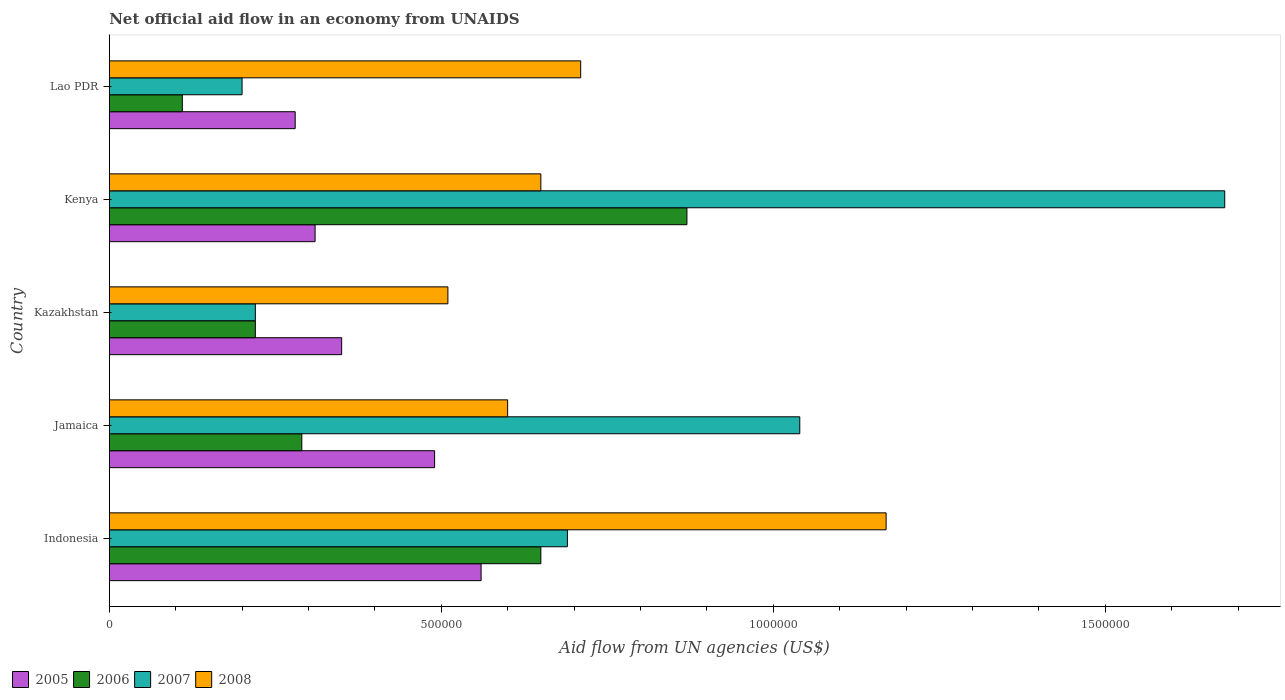How many groups of bars are there?
Keep it short and to the point. 5. How many bars are there on the 3rd tick from the top?
Make the answer very short. 4. What is the label of the 4th group of bars from the top?
Offer a terse response. Jamaica. In how many cases, is the number of bars for a given country not equal to the number of legend labels?
Your answer should be compact. 0. What is the net official aid flow in 2006 in Jamaica?
Give a very brief answer. 2.90e+05. Across all countries, what is the maximum net official aid flow in 2006?
Offer a terse response. 8.70e+05. In which country was the net official aid flow in 2005 minimum?
Provide a short and direct response. Lao PDR. What is the total net official aid flow in 2007 in the graph?
Keep it short and to the point. 3.83e+06. What is the difference between the net official aid flow in 2008 in Indonesia and that in Kenya?
Offer a terse response. 5.20e+05. What is the difference between the net official aid flow in 2005 in Kazakhstan and the net official aid flow in 2007 in Jamaica?
Keep it short and to the point. -6.90e+05. What is the average net official aid flow in 2006 per country?
Provide a short and direct response. 4.28e+05. What is the difference between the net official aid flow in 2008 and net official aid flow in 2006 in Indonesia?
Your answer should be very brief. 5.20e+05. Is the difference between the net official aid flow in 2008 in Kazakhstan and Kenya greater than the difference between the net official aid flow in 2006 in Kazakhstan and Kenya?
Make the answer very short. Yes. What is the difference between the highest and the second highest net official aid flow in 2007?
Offer a terse response. 6.40e+05. What is the difference between the highest and the lowest net official aid flow in 2006?
Provide a succinct answer. 7.60e+05. Is the sum of the net official aid flow in 2006 in Indonesia and Jamaica greater than the maximum net official aid flow in 2005 across all countries?
Provide a succinct answer. Yes. Is it the case that in every country, the sum of the net official aid flow in 2007 and net official aid flow in 2005 is greater than the sum of net official aid flow in 2006 and net official aid flow in 2008?
Ensure brevity in your answer.  No. What does the 2nd bar from the top in Kenya represents?
Provide a short and direct response. 2007. Is it the case that in every country, the sum of the net official aid flow in 2006 and net official aid flow in 2007 is greater than the net official aid flow in 2005?
Offer a very short reply. Yes. How many bars are there?
Offer a very short reply. 20. How many countries are there in the graph?
Provide a short and direct response. 5. What is the difference between two consecutive major ticks on the X-axis?
Offer a very short reply. 5.00e+05. Are the values on the major ticks of X-axis written in scientific E-notation?
Your response must be concise. No. Does the graph contain any zero values?
Give a very brief answer. No. Where does the legend appear in the graph?
Your answer should be compact. Bottom left. How many legend labels are there?
Provide a succinct answer. 4. How are the legend labels stacked?
Your answer should be very brief. Horizontal. What is the title of the graph?
Your response must be concise. Net official aid flow in an economy from UNAIDS. What is the label or title of the X-axis?
Your answer should be compact. Aid flow from UN agencies (US$). What is the label or title of the Y-axis?
Provide a succinct answer. Country. What is the Aid flow from UN agencies (US$) of 2005 in Indonesia?
Give a very brief answer. 5.60e+05. What is the Aid flow from UN agencies (US$) in 2006 in Indonesia?
Offer a very short reply. 6.50e+05. What is the Aid flow from UN agencies (US$) in 2007 in Indonesia?
Offer a very short reply. 6.90e+05. What is the Aid flow from UN agencies (US$) of 2008 in Indonesia?
Offer a terse response. 1.17e+06. What is the Aid flow from UN agencies (US$) in 2005 in Jamaica?
Give a very brief answer. 4.90e+05. What is the Aid flow from UN agencies (US$) in 2007 in Jamaica?
Your response must be concise. 1.04e+06. What is the Aid flow from UN agencies (US$) in 2008 in Jamaica?
Offer a very short reply. 6.00e+05. What is the Aid flow from UN agencies (US$) of 2006 in Kazakhstan?
Offer a terse response. 2.20e+05. What is the Aid flow from UN agencies (US$) in 2007 in Kazakhstan?
Your answer should be compact. 2.20e+05. What is the Aid flow from UN agencies (US$) of 2008 in Kazakhstan?
Your answer should be very brief. 5.10e+05. What is the Aid flow from UN agencies (US$) in 2006 in Kenya?
Provide a succinct answer. 8.70e+05. What is the Aid flow from UN agencies (US$) of 2007 in Kenya?
Provide a succinct answer. 1.68e+06. What is the Aid flow from UN agencies (US$) of 2008 in Kenya?
Your answer should be very brief. 6.50e+05. What is the Aid flow from UN agencies (US$) in 2005 in Lao PDR?
Your response must be concise. 2.80e+05. What is the Aid flow from UN agencies (US$) of 2006 in Lao PDR?
Give a very brief answer. 1.10e+05. What is the Aid flow from UN agencies (US$) in 2007 in Lao PDR?
Your answer should be compact. 2.00e+05. What is the Aid flow from UN agencies (US$) of 2008 in Lao PDR?
Ensure brevity in your answer.  7.10e+05. Across all countries, what is the maximum Aid flow from UN agencies (US$) in 2005?
Provide a short and direct response. 5.60e+05. Across all countries, what is the maximum Aid flow from UN agencies (US$) in 2006?
Provide a succinct answer. 8.70e+05. Across all countries, what is the maximum Aid flow from UN agencies (US$) of 2007?
Offer a terse response. 1.68e+06. Across all countries, what is the maximum Aid flow from UN agencies (US$) of 2008?
Provide a short and direct response. 1.17e+06. Across all countries, what is the minimum Aid flow from UN agencies (US$) in 2005?
Provide a short and direct response. 2.80e+05. Across all countries, what is the minimum Aid flow from UN agencies (US$) in 2006?
Ensure brevity in your answer.  1.10e+05. Across all countries, what is the minimum Aid flow from UN agencies (US$) of 2008?
Offer a very short reply. 5.10e+05. What is the total Aid flow from UN agencies (US$) of 2005 in the graph?
Your response must be concise. 1.99e+06. What is the total Aid flow from UN agencies (US$) in 2006 in the graph?
Offer a very short reply. 2.14e+06. What is the total Aid flow from UN agencies (US$) in 2007 in the graph?
Your answer should be compact. 3.83e+06. What is the total Aid flow from UN agencies (US$) of 2008 in the graph?
Your answer should be very brief. 3.64e+06. What is the difference between the Aid flow from UN agencies (US$) of 2005 in Indonesia and that in Jamaica?
Your response must be concise. 7.00e+04. What is the difference between the Aid flow from UN agencies (US$) in 2006 in Indonesia and that in Jamaica?
Ensure brevity in your answer.  3.60e+05. What is the difference between the Aid flow from UN agencies (US$) in 2007 in Indonesia and that in Jamaica?
Offer a terse response. -3.50e+05. What is the difference between the Aid flow from UN agencies (US$) in 2008 in Indonesia and that in Jamaica?
Make the answer very short. 5.70e+05. What is the difference between the Aid flow from UN agencies (US$) of 2007 in Indonesia and that in Kazakhstan?
Your answer should be compact. 4.70e+05. What is the difference between the Aid flow from UN agencies (US$) in 2008 in Indonesia and that in Kazakhstan?
Your response must be concise. 6.60e+05. What is the difference between the Aid flow from UN agencies (US$) in 2005 in Indonesia and that in Kenya?
Provide a succinct answer. 2.50e+05. What is the difference between the Aid flow from UN agencies (US$) of 2006 in Indonesia and that in Kenya?
Offer a terse response. -2.20e+05. What is the difference between the Aid flow from UN agencies (US$) in 2007 in Indonesia and that in Kenya?
Your answer should be compact. -9.90e+05. What is the difference between the Aid flow from UN agencies (US$) in 2008 in Indonesia and that in Kenya?
Provide a succinct answer. 5.20e+05. What is the difference between the Aid flow from UN agencies (US$) in 2006 in Indonesia and that in Lao PDR?
Offer a very short reply. 5.40e+05. What is the difference between the Aid flow from UN agencies (US$) of 2006 in Jamaica and that in Kazakhstan?
Keep it short and to the point. 7.00e+04. What is the difference between the Aid flow from UN agencies (US$) in 2007 in Jamaica and that in Kazakhstan?
Give a very brief answer. 8.20e+05. What is the difference between the Aid flow from UN agencies (US$) of 2008 in Jamaica and that in Kazakhstan?
Your answer should be very brief. 9.00e+04. What is the difference between the Aid flow from UN agencies (US$) in 2006 in Jamaica and that in Kenya?
Ensure brevity in your answer.  -5.80e+05. What is the difference between the Aid flow from UN agencies (US$) in 2007 in Jamaica and that in Kenya?
Your answer should be very brief. -6.40e+05. What is the difference between the Aid flow from UN agencies (US$) in 2005 in Jamaica and that in Lao PDR?
Your response must be concise. 2.10e+05. What is the difference between the Aid flow from UN agencies (US$) in 2006 in Jamaica and that in Lao PDR?
Offer a terse response. 1.80e+05. What is the difference between the Aid flow from UN agencies (US$) of 2007 in Jamaica and that in Lao PDR?
Your answer should be compact. 8.40e+05. What is the difference between the Aid flow from UN agencies (US$) of 2008 in Jamaica and that in Lao PDR?
Your answer should be compact. -1.10e+05. What is the difference between the Aid flow from UN agencies (US$) in 2006 in Kazakhstan and that in Kenya?
Make the answer very short. -6.50e+05. What is the difference between the Aid flow from UN agencies (US$) of 2007 in Kazakhstan and that in Kenya?
Give a very brief answer. -1.46e+06. What is the difference between the Aid flow from UN agencies (US$) of 2006 in Kazakhstan and that in Lao PDR?
Your answer should be compact. 1.10e+05. What is the difference between the Aid flow from UN agencies (US$) in 2005 in Kenya and that in Lao PDR?
Ensure brevity in your answer.  3.00e+04. What is the difference between the Aid flow from UN agencies (US$) in 2006 in Kenya and that in Lao PDR?
Give a very brief answer. 7.60e+05. What is the difference between the Aid flow from UN agencies (US$) in 2007 in Kenya and that in Lao PDR?
Make the answer very short. 1.48e+06. What is the difference between the Aid flow from UN agencies (US$) of 2008 in Kenya and that in Lao PDR?
Provide a succinct answer. -6.00e+04. What is the difference between the Aid flow from UN agencies (US$) in 2005 in Indonesia and the Aid flow from UN agencies (US$) in 2007 in Jamaica?
Your response must be concise. -4.80e+05. What is the difference between the Aid flow from UN agencies (US$) of 2005 in Indonesia and the Aid flow from UN agencies (US$) of 2008 in Jamaica?
Your answer should be very brief. -4.00e+04. What is the difference between the Aid flow from UN agencies (US$) in 2006 in Indonesia and the Aid flow from UN agencies (US$) in 2007 in Jamaica?
Your answer should be very brief. -3.90e+05. What is the difference between the Aid flow from UN agencies (US$) in 2006 in Indonesia and the Aid flow from UN agencies (US$) in 2008 in Jamaica?
Ensure brevity in your answer.  5.00e+04. What is the difference between the Aid flow from UN agencies (US$) of 2005 in Indonesia and the Aid flow from UN agencies (US$) of 2006 in Kazakhstan?
Your response must be concise. 3.40e+05. What is the difference between the Aid flow from UN agencies (US$) of 2005 in Indonesia and the Aid flow from UN agencies (US$) of 2007 in Kazakhstan?
Your response must be concise. 3.40e+05. What is the difference between the Aid flow from UN agencies (US$) of 2006 in Indonesia and the Aid flow from UN agencies (US$) of 2007 in Kazakhstan?
Your answer should be compact. 4.30e+05. What is the difference between the Aid flow from UN agencies (US$) in 2007 in Indonesia and the Aid flow from UN agencies (US$) in 2008 in Kazakhstan?
Offer a terse response. 1.80e+05. What is the difference between the Aid flow from UN agencies (US$) of 2005 in Indonesia and the Aid flow from UN agencies (US$) of 2006 in Kenya?
Ensure brevity in your answer.  -3.10e+05. What is the difference between the Aid flow from UN agencies (US$) of 2005 in Indonesia and the Aid flow from UN agencies (US$) of 2007 in Kenya?
Offer a very short reply. -1.12e+06. What is the difference between the Aid flow from UN agencies (US$) of 2006 in Indonesia and the Aid flow from UN agencies (US$) of 2007 in Kenya?
Give a very brief answer. -1.03e+06. What is the difference between the Aid flow from UN agencies (US$) in 2006 in Indonesia and the Aid flow from UN agencies (US$) in 2008 in Kenya?
Provide a short and direct response. 0. What is the difference between the Aid flow from UN agencies (US$) of 2005 in Indonesia and the Aid flow from UN agencies (US$) of 2006 in Lao PDR?
Keep it short and to the point. 4.50e+05. What is the difference between the Aid flow from UN agencies (US$) of 2005 in Indonesia and the Aid flow from UN agencies (US$) of 2007 in Lao PDR?
Ensure brevity in your answer.  3.60e+05. What is the difference between the Aid flow from UN agencies (US$) of 2006 in Indonesia and the Aid flow from UN agencies (US$) of 2007 in Lao PDR?
Provide a succinct answer. 4.50e+05. What is the difference between the Aid flow from UN agencies (US$) of 2006 in Indonesia and the Aid flow from UN agencies (US$) of 2008 in Lao PDR?
Give a very brief answer. -6.00e+04. What is the difference between the Aid flow from UN agencies (US$) of 2005 in Jamaica and the Aid flow from UN agencies (US$) of 2007 in Kazakhstan?
Make the answer very short. 2.70e+05. What is the difference between the Aid flow from UN agencies (US$) in 2006 in Jamaica and the Aid flow from UN agencies (US$) in 2007 in Kazakhstan?
Make the answer very short. 7.00e+04. What is the difference between the Aid flow from UN agencies (US$) in 2006 in Jamaica and the Aid flow from UN agencies (US$) in 2008 in Kazakhstan?
Offer a very short reply. -2.20e+05. What is the difference between the Aid flow from UN agencies (US$) of 2007 in Jamaica and the Aid flow from UN agencies (US$) of 2008 in Kazakhstan?
Give a very brief answer. 5.30e+05. What is the difference between the Aid flow from UN agencies (US$) of 2005 in Jamaica and the Aid flow from UN agencies (US$) of 2006 in Kenya?
Offer a very short reply. -3.80e+05. What is the difference between the Aid flow from UN agencies (US$) of 2005 in Jamaica and the Aid flow from UN agencies (US$) of 2007 in Kenya?
Provide a short and direct response. -1.19e+06. What is the difference between the Aid flow from UN agencies (US$) of 2006 in Jamaica and the Aid flow from UN agencies (US$) of 2007 in Kenya?
Ensure brevity in your answer.  -1.39e+06. What is the difference between the Aid flow from UN agencies (US$) in 2006 in Jamaica and the Aid flow from UN agencies (US$) in 2008 in Kenya?
Provide a succinct answer. -3.60e+05. What is the difference between the Aid flow from UN agencies (US$) of 2005 in Jamaica and the Aid flow from UN agencies (US$) of 2006 in Lao PDR?
Provide a succinct answer. 3.80e+05. What is the difference between the Aid flow from UN agencies (US$) of 2005 in Jamaica and the Aid flow from UN agencies (US$) of 2008 in Lao PDR?
Ensure brevity in your answer.  -2.20e+05. What is the difference between the Aid flow from UN agencies (US$) of 2006 in Jamaica and the Aid flow from UN agencies (US$) of 2007 in Lao PDR?
Your answer should be very brief. 9.00e+04. What is the difference between the Aid flow from UN agencies (US$) of 2006 in Jamaica and the Aid flow from UN agencies (US$) of 2008 in Lao PDR?
Provide a short and direct response. -4.20e+05. What is the difference between the Aid flow from UN agencies (US$) in 2005 in Kazakhstan and the Aid flow from UN agencies (US$) in 2006 in Kenya?
Ensure brevity in your answer.  -5.20e+05. What is the difference between the Aid flow from UN agencies (US$) of 2005 in Kazakhstan and the Aid flow from UN agencies (US$) of 2007 in Kenya?
Offer a terse response. -1.33e+06. What is the difference between the Aid flow from UN agencies (US$) in 2005 in Kazakhstan and the Aid flow from UN agencies (US$) in 2008 in Kenya?
Your answer should be very brief. -3.00e+05. What is the difference between the Aid flow from UN agencies (US$) in 2006 in Kazakhstan and the Aid flow from UN agencies (US$) in 2007 in Kenya?
Keep it short and to the point. -1.46e+06. What is the difference between the Aid flow from UN agencies (US$) in 2006 in Kazakhstan and the Aid flow from UN agencies (US$) in 2008 in Kenya?
Ensure brevity in your answer.  -4.30e+05. What is the difference between the Aid flow from UN agencies (US$) of 2007 in Kazakhstan and the Aid flow from UN agencies (US$) of 2008 in Kenya?
Make the answer very short. -4.30e+05. What is the difference between the Aid flow from UN agencies (US$) of 2005 in Kazakhstan and the Aid flow from UN agencies (US$) of 2006 in Lao PDR?
Offer a terse response. 2.40e+05. What is the difference between the Aid flow from UN agencies (US$) in 2005 in Kazakhstan and the Aid flow from UN agencies (US$) in 2008 in Lao PDR?
Keep it short and to the point. -3.60e+05. What is the difference between the Aid flow from UN agencies (US$) in 2006 in Kazakhstan and the Aid flow from UN agencies (US$) in 2007 in Lao PDR?
Provide a succinct answer. 2.00e+04. What is the difference between the Aid flow from UN agencies (US$) in 2006 in Kazakhstan and the Aid flow from UN agencies (US$) in 2008 in Lao PDR?
Offer a terse response. -4.90e+05. What is the difference between the Aid flow from UN agencies (US$) in 2007 in Kazakhstan and the Aid flow from UN agencies (US$) in 2008 in Lao PDR?
Ensure brevity in your answer.  -4.90e+05. What is the difference between the Aid flow from UN agencies (US$) of 2005 in Kenya and the Aid flow from UN agencies (US$) of 2006 in Lao PDR?
Your answer should be compact. 2.00e+05. What is the difference between the Aid flow from UN agencies (US$) of 2005 in Kenya and the Aid flow from UN agencies (US$) of 2007 in Lao PDR?
Your response must be concise. 1.10e+05. What is the difference between the Aid flow from UN agencies (US$) in 2005 in Kenya and the Aid flow from UN agencies (US$) in 2008 in Lao PDR?
Your answer should be compact. -4.00e+05. What is the difference between the Aid flow from UN agencies (US$) of 2006 in Kenya and the Aid flow from UN agencies (US$) of 2007 in Lao PDR?
Ensure brevity in your answer.  6.70e+05. What is the difference between the Aid flow from UN agencies (US$) of 2006 in Kenya and the Aid flow from UN agencies (US$) of 2008 in Lao PDR?
Your answer should be compact. 1.60e+05. What is the difference between the Aid flow from UN agencies (US$) in 2007 in Kenya and the Aid flow from UN agencies (US$) in 2008 in Lao PDR?
Ensure brevity in your answer.  9.70e+05. What is the average Aid flow from UN agencies (US$) in 2005 per country?
Make the answer very short. 3.98e+05. What is the average Aid flow from UN agencies (US$) of 2006 per country?
Give a very brief answer. 4.28e+05. What is the average Aid flow from UN agencies (US$) in 2007 per country?
Give a very brief answer. 7.66e+05. What is the average Aid flow from UN agencies (US$) in 2008 per country?
Offer a very short reply. 7.28e+05. What is the difference between the Aid flow from UN agencies (US$) of 2005 and Aid flow from UN agencies (US$) of 2006 in Indonesia?
Your answer should be compact. -9.00e+04. What is the difference between the Aid flow from UN agencies (US$) in 2005 and Aid flow from UN agencies (US$) in 2008 in Indonesia?
Your answer should be very brief. -6.10e+05. What is the difference between the Aid flow from UN agencies (US$) of 2006 and Aid flow from UN agencies (US$) of 2008 in Indonesia?
Give a very brief answer. -5.20e+05. What is the difference between the Aid flow from UN agencies (US$) of 2007 and Aid flow from UN agencies (US$) of 2008 in Indonesia?
Provide a short and direct response. -4.80e+05. What is the difference between the Aid flow from UN agencies (US$) in 2005 and Aid flow from UN agencies (US$) in 2006 in Jamaica?
Your answer should be very brief. 2.00e+05. What is the difference between the Aid flow from UN agencies (US$) of 2005 and Aid flow from UN agencies (US$) of 2007 in Jamaica?
Give a very brief answer. -5.50e+05. What is the difference between the Aid flow from UN agencies (US$) in 2005 and Aid flow from UN agencies (US$) in 2008 in Jamaica?
Make the answer very short. -1.10e+05. What is the difference between the Aid flow from UN agencies (US$) in 2006 and Aid flow from UN agencies (US$) in 2007 in Jamaica?
Your response must be concise. -7.50e+05. What is the difference between the Aid flow from UN agencies (US$) in 2006 and Aid flow from UN agencies (US$) in 2008 in Jamaica?
Provide a succinct answer. -3.10e+05. What is the difference between the Aid flow from UN agencies (US$) in 2007 and Aid flow from UN agencies (US$) in 2008 in Jamaica?
Your response must be concise. 4.40e+05. What is the difference between the Aid flow from UN agencies (US$) of 2005 and Aid flow from UN agencies (US$) of 2006 in Kazakhstan?
Your response must be concise. 1.30e+05. What is the difference between the Aid flow from UN agencies (US$) of 2007 and Aid flow from UN agencies (US$) of 2008 in Kazakhstan?
Your answer should be compact. -2.90e+05. What is the difference between the Aid flow from UN agencies (US$) in 2005 and Aid flow from UN agencies (US$) in 2006 in Kenya?
Offer a terse response. -5.60e+05. What is the difference between the Aid flow from UN agencies (US$) of 2005 and Aid flow from UN agencies (US$) of 2007 in Kenya?
Ensure brevity in your answer.  -1.37e+06. What is the difference between the Aid flow from UN agencies (US$) in 2006 and Aid flow from UN agencies (US$) in 2007 in Kenya?
Make the answer very short. -8.10e+05. What is the difference between the Aid flow from UN agencies (US$) in 2006 and Aid flow from UN agencies (US$) in 2008 in Kenya?
Ensure brevity in your answer.  2.20e+05. What is the difference between the Aid flow from UN agencies (US$) in 2007 and Aid flow from UN agencies (US$) in 2008 in Kenya?
Offer a terse response. 1.03e+06. What is the difference between the Aid flow from UN agencies (US$) of 2005 and Aid flow from UN agencies (US$) of 2008 in Lao PDR?
Provide a short and direct response. -4.30e+05. What is the difference between the Aid flow from UN agencies (US$) of 2006 and Aid flow from UN agencies (US$) of 2007 in Lao PDR?
Give a very brief answer. -9.00e+04. What is the difference between the Aid flow from UN agencies (US$) in 2006 and Aid flow from UN agencies (US$) in 2008 in Lao PDR?
Keep it short and to the point. -6.00e+05. What is the difference between the Aid flow from UN agencies (US$) in 2007 and Aid flow from UN agencies (US$) in 2008 in Lao PDR?
Offer a very short reply. -5.10e+05. What is the ratio of the Aid flow from UN agencies (US$) in 2006 in Indonesia to that in Jamaica?
Offer a very short reply. 2.24. What is the ratio of the Aid flow from UN agencies (US$) in 2007 in Indonesia to that in Jamaica?
Give a very brief answer. 0.66. What is the ratio of the Aid flow from UN agencies (US$) in 2008 in Indonesia to that in Jamaica?
Provide a short and direct response. 1.95. What is the ratio of the Aid flow from UN agencies (US$) of 2005 in Indonesia to that in Kazakhstan?
Ensure brevity in your answer.  1.6. What is the ratio of the Aid flow from UN agencies (US$) in 2006 in Indonesia to that in Kazakhstan?
Give a very brief answer. 2.95. What is the ratio of the Aid flow from UN agencies (US$) in 2007 in Indonesia to that in Kazakhstan?
Offer a terse response. 3.14. What is the ratio of the Aid flow from UN agencies (US$) in 2008 in Indonesia to that in Kazakhstan?
Your answer should be very brief. 2.29. What is the ratio of the Aid flow from UN agencies (US$) in 2005 in Indonesia to that in Kenya?
Make the answer very short. 1.81. What is the ratio of the Aid flow from UN agencies (US$) of 2006 in Indonesia to that in Kenya?
Provide a short and direct response. 0.75. What is the ratio of the Aid flow from UN agencies (US$) of 2007 in Indonesia to that in Kenya?
Your response must be concise. 0.41. What is the ratio of the Aid flow from UN agencies (US$) in 2008 in Indonesia to that in Kenya?
Provide a succinct answer. 1.8. What is the ratio of the Aid flow from UN agencies (US$) in 2006 in Indonesia to that in Lao PDR?
Give a very brief answer. 5.91. What is the ratio of the Aid flow from UN agencies (US$) in 2007 in Indonesia to that in Lao PDR?
Offer a terse response. 3.45. What is the ratio of the Aid flow from UN agencies (US$) in 2008 in Indonesia to that in Lao PDR?
Keep it short and to the point. 1.65. What is the ratio of the Aid flow from UN agencies (US$) in 2006 in Jamaica to that in Kazakhstan?
Offer a terse response. 1.32. What is the ratio of the Aid flow from UN agencies (US$) of 2007 in Jamaica to that in Kazakhstan?
Offer a terse response. 4.73. What is the ratio of the Aid flow from UN agencies (US$) in 2008 in Jamaica to that in Kazakhstan?
Ensure brevity in your answer.  1.18. What is the ratio of the Aid flow from UN agencies (US$) of 2005 in Jamaica to that in Kenya?
Make the answer very short. 1.58. What is the ratio of the Aid flow from UN agencies (US$) of 2006 in Jamaica to that in Kenya?
Keep it short and to the point. 0.33. What is the ratio of the Aid flow from UN agencies (US$) of 2007 in Jamaica to that in Kenya?
Provide a succinct answer. 0.62. What is the ratio of the Aid flow from UN agencies (US$) of 2006 in Jamaica to that in Lao PDR?
Your answer should be compact. 2.64. What is the ratio of the Aid flow from UN agencies (US$) in 2008 in Jamaica to that in Lao PDR?
Your response must be concise. 0.85. What is the ratio of the Aid flow from UN agencies (US$) in 2005 in Kazakhstan to that in Kenya?
Your answer should be very brief. 1.13. What is the ratio of the Aid flow from UN agencies (US$) in 2006 in Kazakhstan to that in Kenya?
Your response must be concise. 0.25. What is the ratio of the Aid flow from UN agencies (US$) of 2007 in Kazakhstan to that in Kenya?
Provide a succinct answer. 0.13. What is the ratio of the Aid flow from UN agencies (US$) in 2008 in Kazakhstan to that in Kenya?
Provide a short and direct response. 0.78. What is the ratio of the Aid flow from UN agencies (US$) in 2005 in Kazakhstan to that in Lao PDR?
Give a very brief answer. 1.25. What is the ratio of the Aid flow from UN agencies (US$) of 2008 in Kazakhstan to that in Lao PDR?
Provide a short and direct response. 0.72. What is the ratio of the Aid flow from UN agencies (US$) in 2005 in Kenya to that in Lao PDR?
Make the answer very short. 1.11. What is the ratio of the Aid flow from UN agencies (US$) in 2006 in Kenya to that in Lao PDR?
Keep it short and to the point. 7.91. What is the ratio of the Aid flow from UN agencies (US$) in 2008 in Kenya to that in Lao PDR?
Keep it short and to the point. 0.92. What is the difference between the highest and the second highest Aid flow from UN agencies (US$) in 2007?
Your answer should be compact. 6.40e+05. What is the difference between the highest and the second highest Aid flow from UN agencies (US$) in 2008?
Provide a succinct answer. 4.60e+05. What is the difference between the highest and the lowest Aid flow from UN agencies (US$) in 2006?
Keep it short and to the point. 7.60e+05. What is the difference between the highest and the lowest Aid flow from UN agencies (US$) in 2007?
Offer a very short reply. 1.48e+06. What is the difference between the highest and the lowest Aid flow from UN agencies (US$) of 2008?
Ensure brevity in your answer.  6.60e+05. 